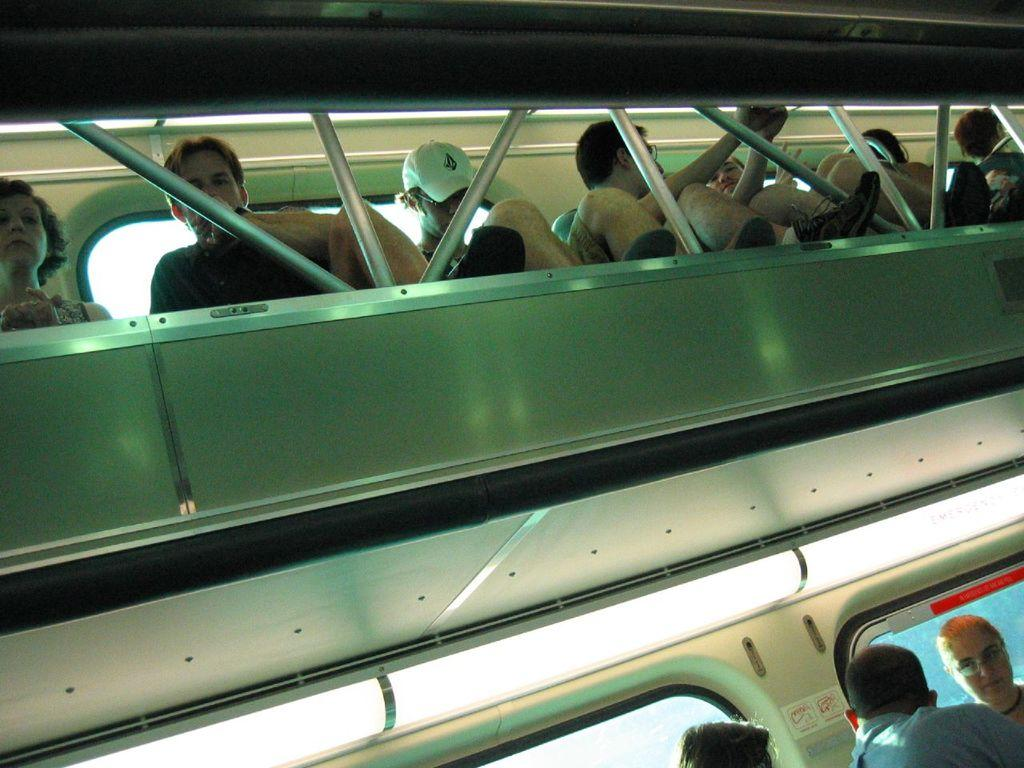What type of setting is depicted in the image? The image shows an inside view of a vehicle. Can you describe the people present in the vehicle? Unfortunately, the facts provided do not give any details about the people in the vehicle. What might the people be doing in the vehicle? The facts provided do not give any information about the activities of the people in the vehicle. What type of wing is attached to the doll in the image? There is no doll or wing present in the image. What type of station is visible in the background of the image? There is no station visible in the image; it shows an inside view of a vehicle. 